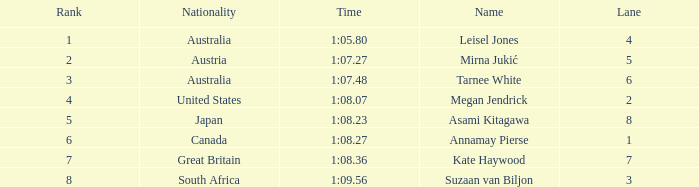What is the Nationality of the Swimmer in Lane 4 or larger with a Rank of 5 or more? Great Britain. 